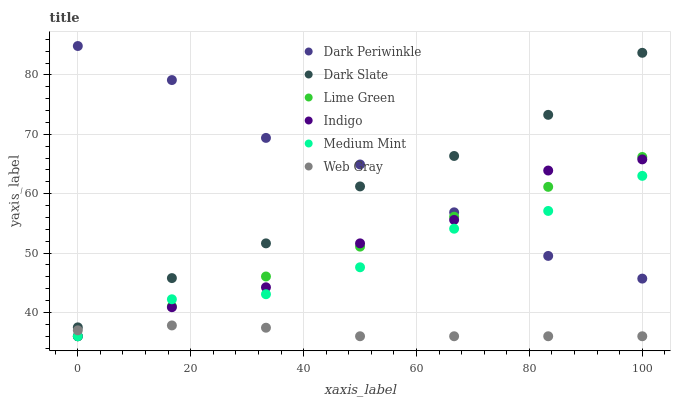Does Web Gray have the minimum area under the curve?
Answer yes or no. Yes. Does Dark Periwinkle have the maximum area under the curve?
Answer yes or no. Yes. Does Indigo have the minimum area under the curve?
Answer yes or no. No. Does Indigo have the maximum area under the curve?
Answer yes or no. No. Is Lime Green the smoothest?
Answer yes or no. Yes. Is Indigo the roughest?
Answer yes or no. Yes. Is Web Gray the smoothest?
Answer yes or no. No. Is Web Gray the roughest?
Answer yes or no. No. Does Medium Mint have the lowest value?
Answer yes or no. Yes. Does Dark Slate have the lowest value?
Answer yes or no. No. Does Dark Periwinkle have the highest value?
Answer yes or no. Yes. Does Indigo have the highest value?
Answer yes or no. No. Is Web Gray less than Dark Slate?
Answer yes or no. Yes. Is Dark Slate greater than Medium Mint?
Answer yes or no. Yes. Does Dark Periwinkle intersect Indigo?
Answer yes or no. Yes. Is Dark Periwinkle less than Indigo?
Answer yes or no. No. Is Dark Periwinkle greater than Indigo?
Answer yes or no. No. Does Web Gray intersect Dark Slate?
Answer yes or no. No. 